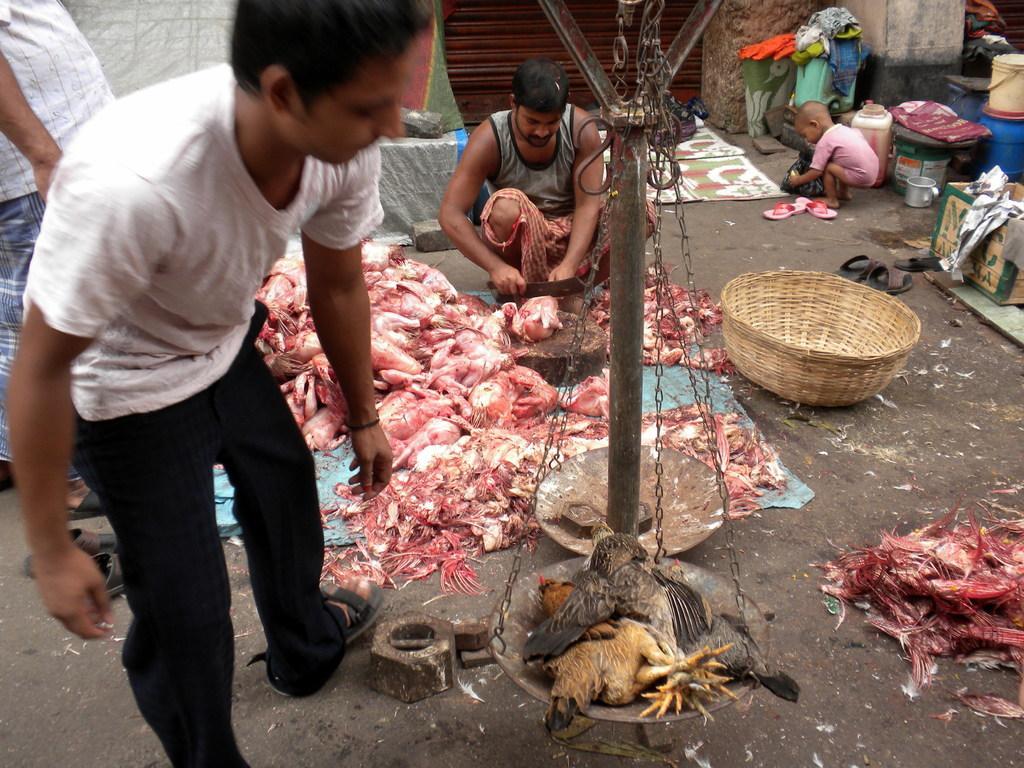Describe this image in one or two sentences. In this picture I can see many chickens on this carpet. At the top there is a man who is cutting the chicken pieces. On the left there is a man who is standing near to the weight machine. On the right there is a baby boy who is standing near to the shelter, barrel, box, clothes, cotton boxes and other objects. 